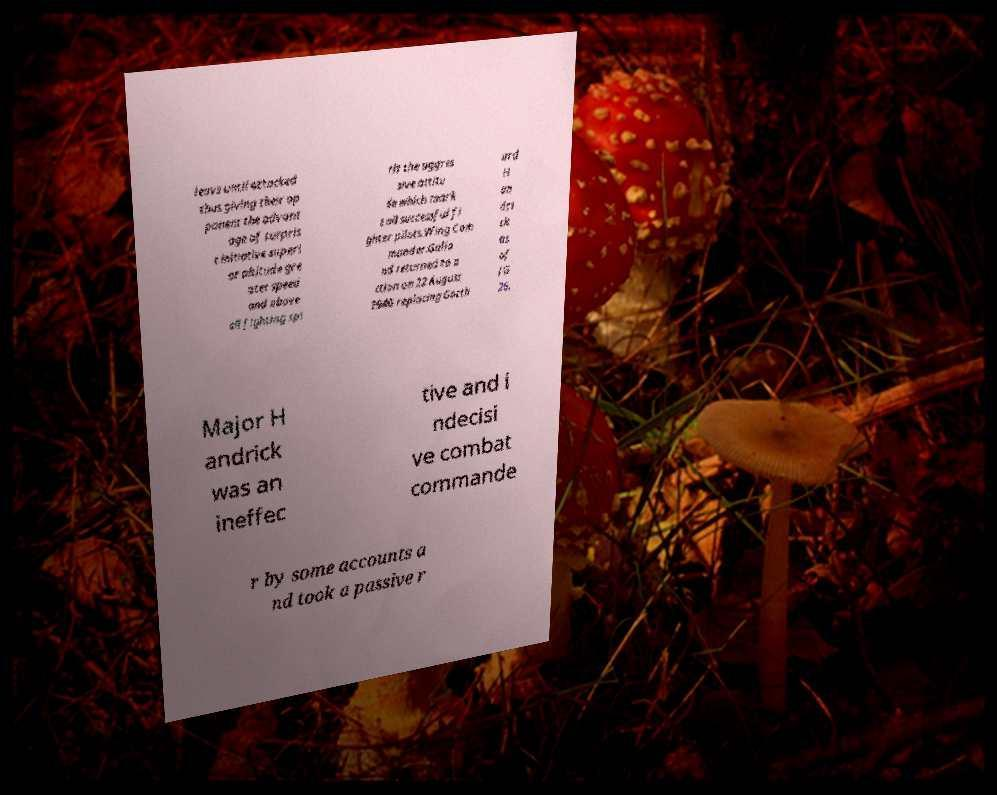I need the written content from this picture converted into text. Can you do that? leave until attacked thus giving their op ponent the advant age of surpris e initiative superi or altitude gre ater speed and above all fighting spi rit the aggres sive attitu de which mark s all successful fi ghter pilots.Wing Com mander.Galla nd returned to a ction on 22 August 1940 replacing Gotth ard H an dri ck as of JG 26. Major H andrick was an ineffec tive and i ndecisi ve combat commande r by some accounts a nd took a passive r 